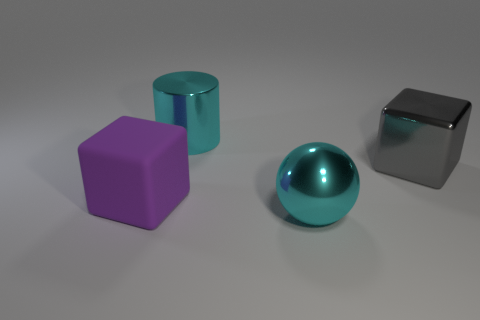How do the shadows cast by the objects compare? The shadows cast by the objects indicate a consistent light source from the upper right. The shadows are soft-edged, suggesting a diffuse light source, possibly in an indoor environment. The sphere creates a rounded shadow, while the cubes cast angular shadows, which are congruent with their shapes. 